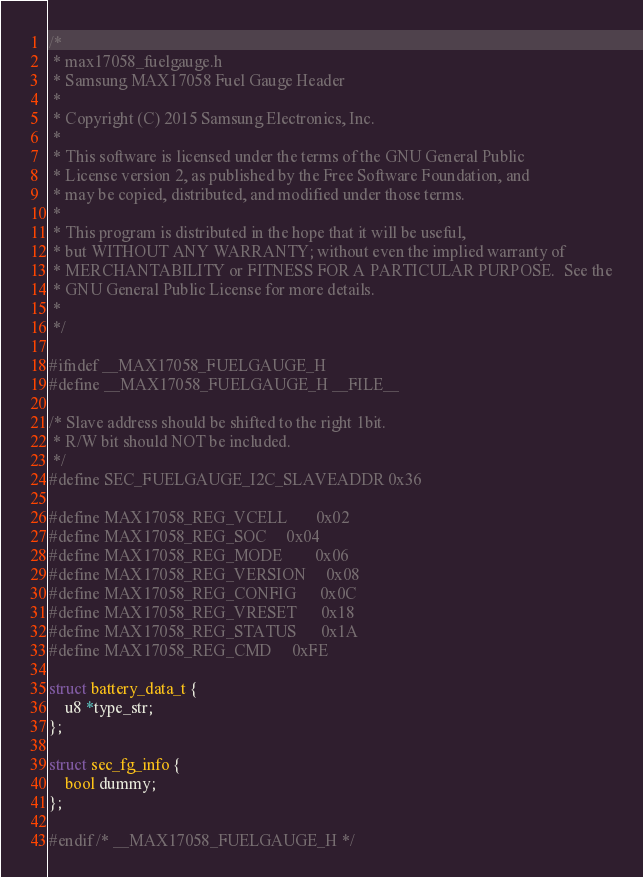<code> <loc_0><loc_0><loc_500><loc_500><_C_>/*
 * max17058_fuelgauge.h
 * Samsung MAX17058 Fuel Gauge Header
 *
 * Copyright (C) 2015 Samsung Electronics, Inc.
 *
 * This software is licensed under the terms of the GNU General Public
 * License version 2, as published by the Free Software Foundation, and
 * may be copied, distributed, and modified under those terms.
 *
 * This program is distributed in the hope that it will be useful,
 * but WITHOUT ANY WARRANTY; without even the implied warranty of
 * MERCHANTABILITY or FITNESS FOR A PARTICULAR PURPOSE.  See the
 * GNU General Public License for more details.
 *
 */

#ifndef __MAX17058_FUELGAUGE_H
#define __MAX17058_FUELGAUGE_H __FILE__

/* Slave address should be shifted to the right 1bit.
 * R/W bit should NOT be included.
 */
#define SEC_FUELGAUGE_I2C_SLAVEADDR 0x36

#define MAX17058_REG_VCELL		0x02
#define MAX17058_REG_SOC		0x04
#define MAX17058_REG_MODE		0x06
#define MAX17058_REG_VERSION		0x08
#define MAX17058_REG_CONFIG		0x0C
#define MAX17058_REG_VRESET		0x18
#define MAX17058_REG_STATUS		0x1A
#define MAX17058_REG_CMD		0xFE

struct battery_data_t {
	u8 *type_str;
};

struct sec_fg_info {
	bool dummy;
};

#endif /* __MAX17058_FUELGAUGE_H */
</code> 